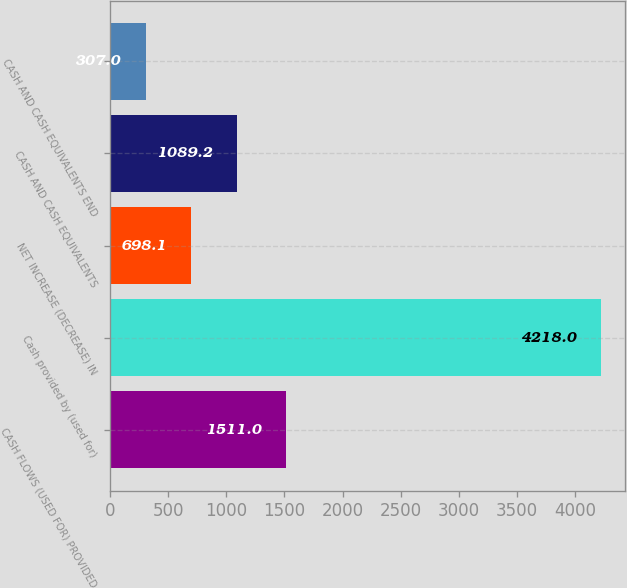Convert chart. <chart><loc_0><loc_0><loc_500><loc_500><bar_chart><fcel>CASH FLOWS (USED FOR) PROVIDED<fcel>Cash provided by (used for)<fcel>NET INCREASE (DECREASE) IN<fcel>CASH AND CASH EQUIVALENTS<fcel>CASH AND CASH EQUIVALENTS END<nl><fcel>1511<fcel>4218<fcel>698.1<fcel>1089.2<fcel>307<nl></chart> 